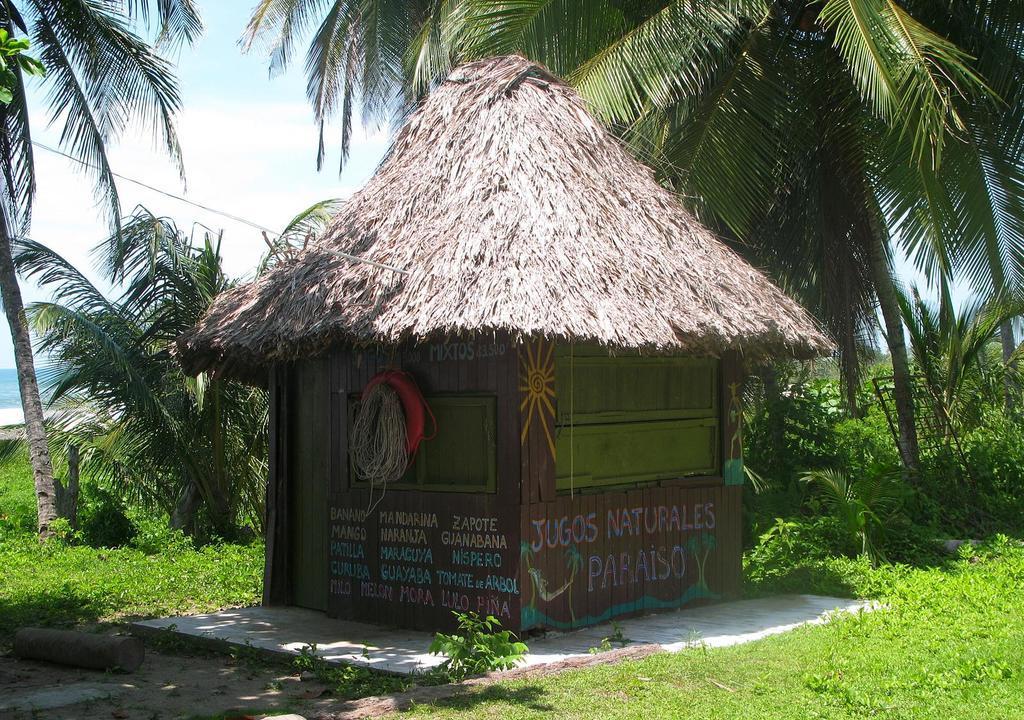Could you give a brief overview of what you see in this image? In this image in the middle there are trees, house, rope, tube, plants, grass, sky and clouds. 